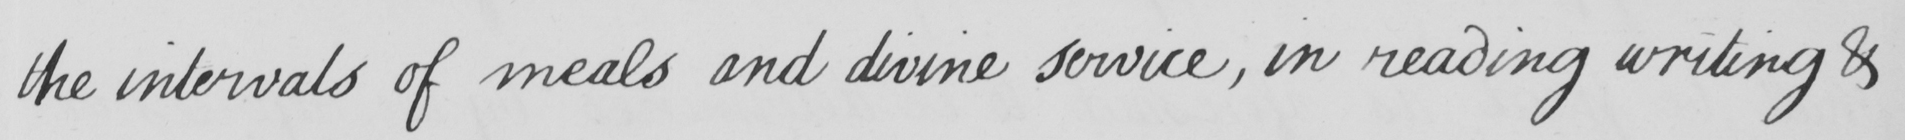Please transcribe the handwritten text in this image. the intervals of meals and divine service , in reading writing & 